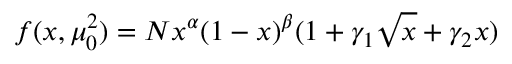Convert formula to latex. <formula><loc_0><loc_0><loc_500><loc_500>f ( x , \mu _ { 0 } ^ { 2 } ) = N x ^ { \alpha } ( 1 - x ) ^ { \beta } ( 1 + \gamma _ { 1 } \sqrt { x } + \gamma _ { 2 } x ) \,</formula> 